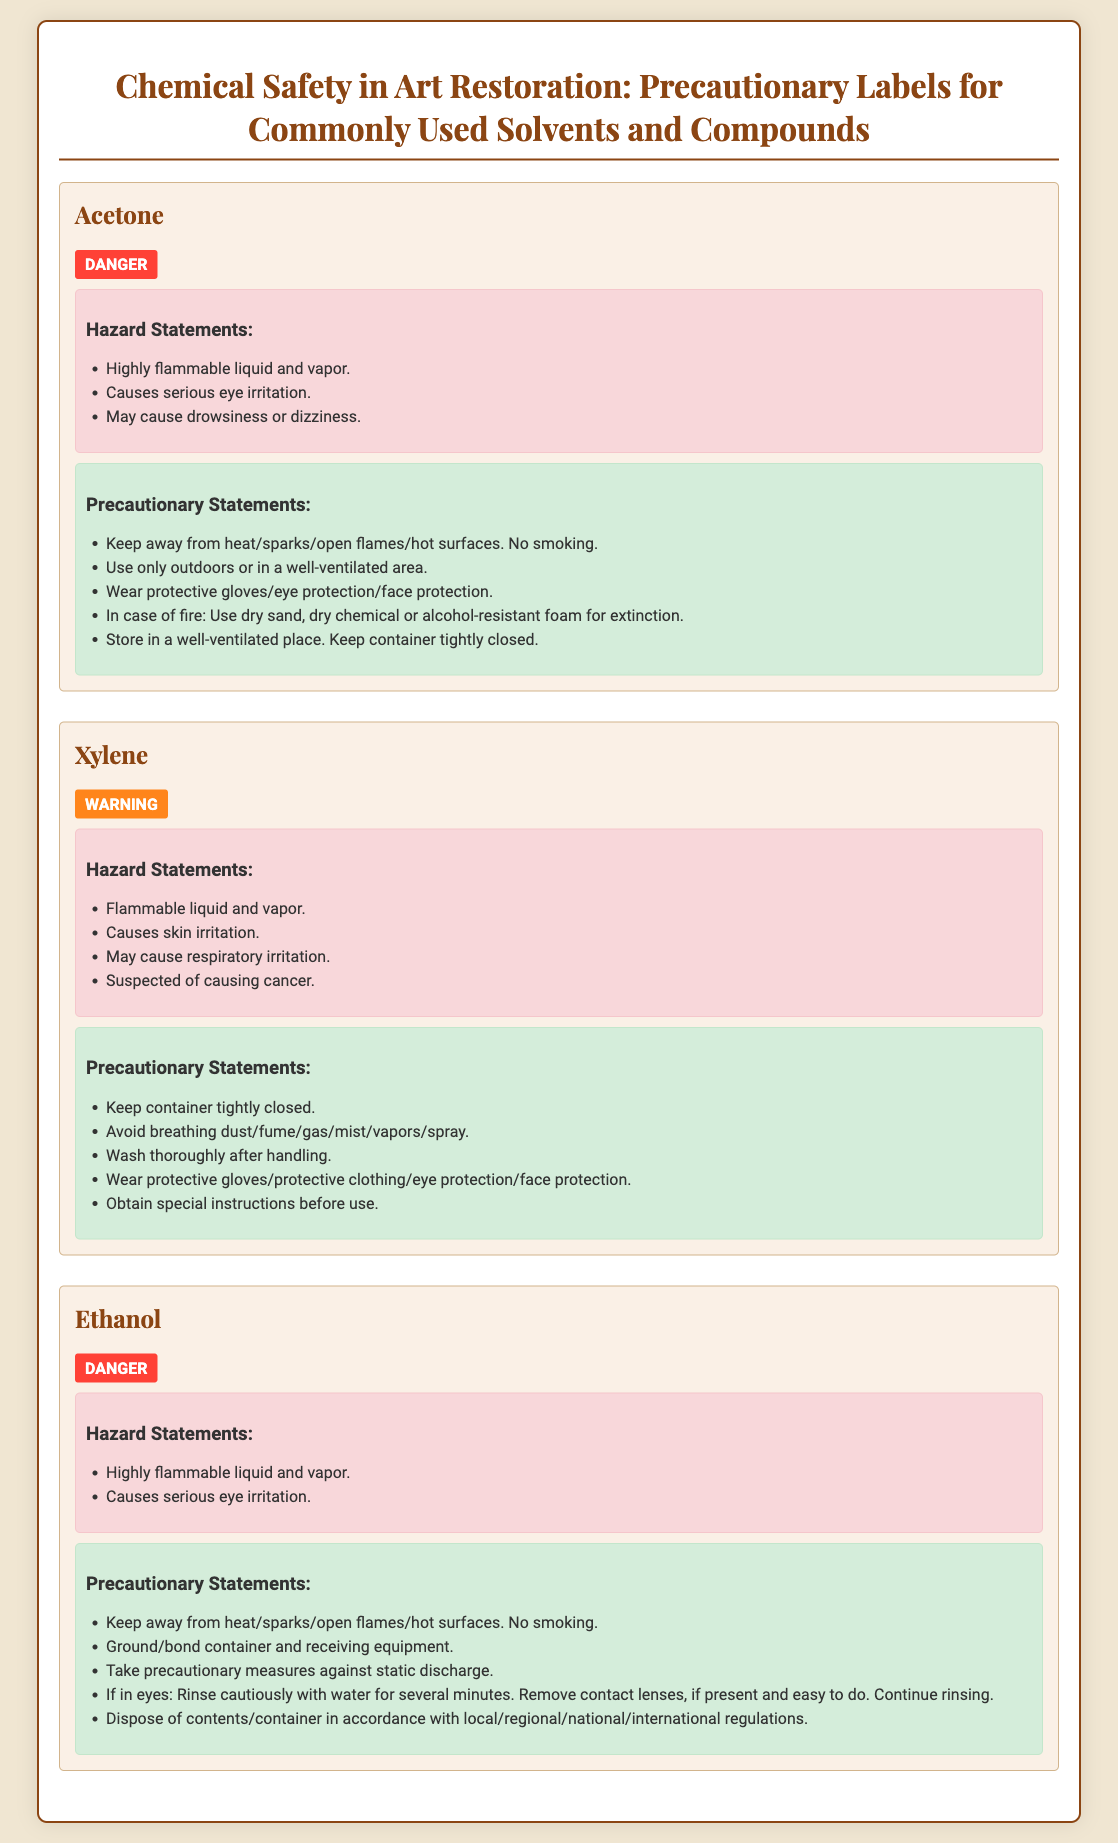What is the first chemical listed? The first chemical mentioned in the document is Acetone.
Answer: Acetone What type of signal word is associated with Xylene? The document indicates that Xylene has a warning signal word.
Answer: WARNING How many hazard statements are listed for Ethanol? There are two hazard statements provided for Ethanol in the document.
Answer: 2 What precautionary action should be taken if Acetone catches fire? The document states to use dry sand, dry chemical or alcohol-resistant foam for extinction.
Answer: Use dry sand, dry chemical or alcohol-resistant foam What is the main risk associated with Xylene mentioned in the hazard statements? The document notes that Xylene is suspected of causing cancer among other risks.
Answer: Suspected of causing cancer What should be done after handling Xylene? The precautionary statement advises to wash thoroughly after handling Xylene.
Answer: Wash thoroughly after handling Which chemical has a precaution about rinsing eyes if contact occurs? The precautionary statements for Ethanol specify advising rinsing cautiously with water in case of eye contact.
Answer: Ethanol What is a common precautionary statement for both Acetone and Ethanol? Both Acetone and Ethanol precautions include keeping away from heat/sparks/open flames/hot surfaces.
Answer: Keep away from heat/sparks/open flames/hot surfaces 